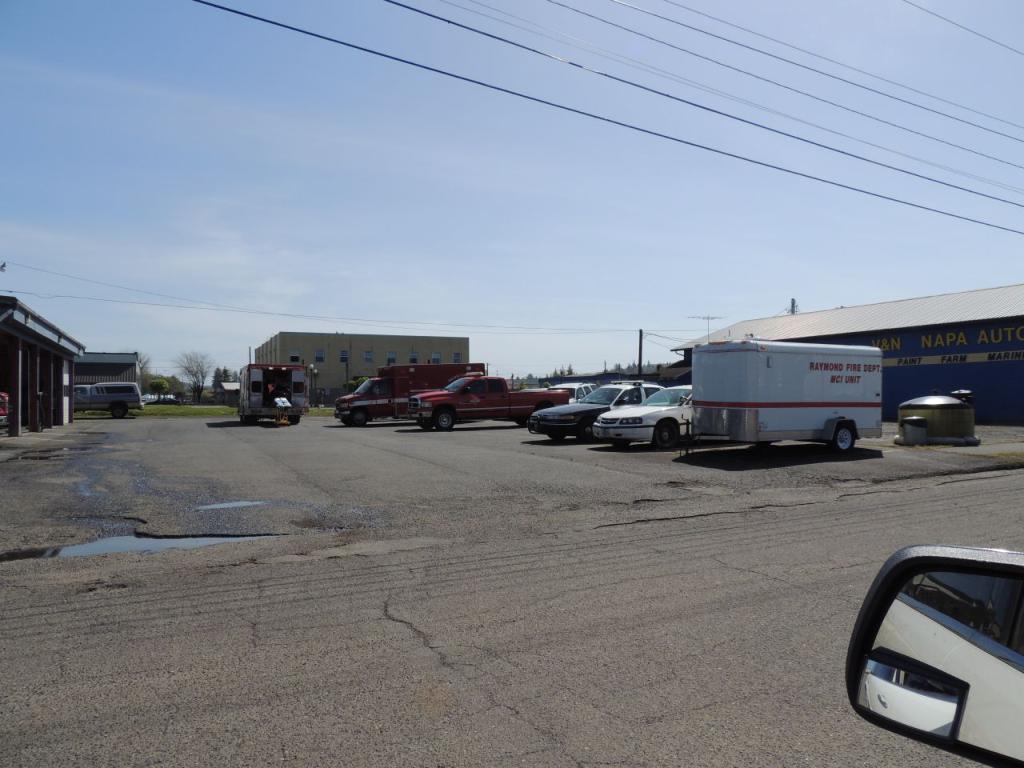How would you summarize this image in a sentence or two? Here in this picture we can see number of cars, trucks and vans present on the road over there and we can also see buildings and stores here and there and we can see trees and plants in the far and we can also see electric poles with wires hanging on it over there and we can also see clouds in the sky. 